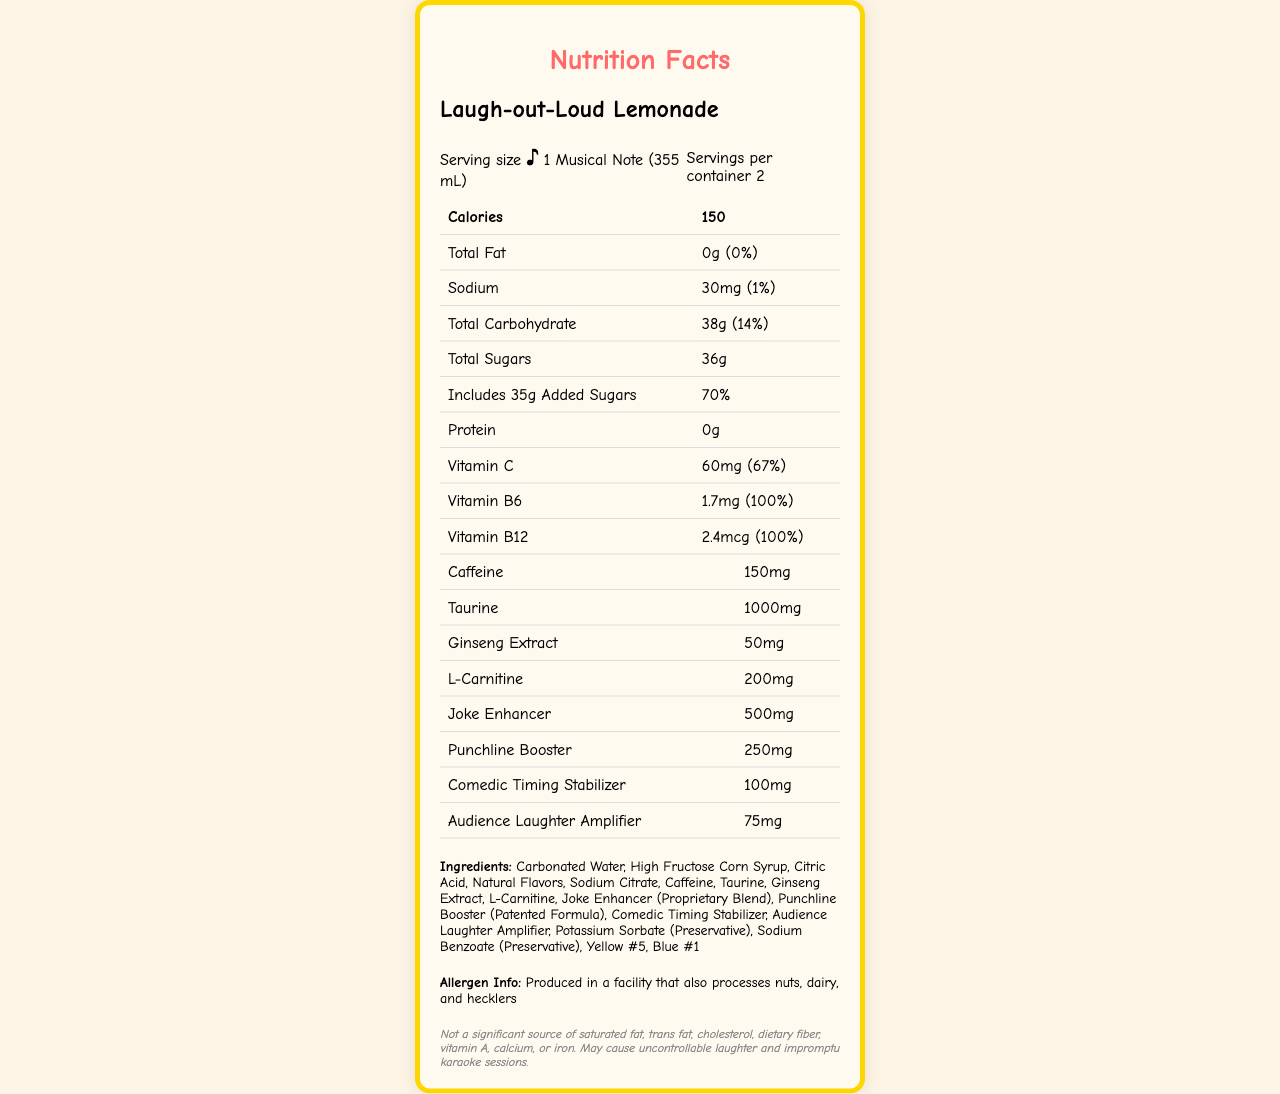what is the serving size? The serving size is stated as "1 Musical Note (355 mL)" in the serving information section at the top of the document.
Answer: 1 Musical Note (355 mL) how many calories are there per serving? The number of calories per serving is listed at the top of the nutrition information table as "Calories: 150."
Answer: 150 how much Vitamin C is in this drink? The amount of Vitamin C is given in the nutrition information table as "Vitamin C: 60mg (67%)."
Answer: 60mg (67% DV) what is the daily value percentage for added sugars? The daily value percentage for added sugars is listed as "70%" in the nutrition information table under "Includes 35g Added Sugars."
Answer: 70% list three key ingredients in the "Laugh-out-Loud Lemonade". The ingredients section lists "Carbonated Water, High Fructose Corn Syrup, Citric Acid" among other ingredients.
Answer: Carbonated Water, High Fructose Corn Syrup, Citric Acid how many servings are there per container? A. 1 B. 2 C. 3 D. 4 The servings per container are listed as "2" in the serving information section.
Answer: B which nutrient has the highest daily value percentage? i. Vitamin C ii. Vitamin B6 iii. Total Sugars iv. Sodium Vitamin B6 and Vitamin B12 both have a 100% daily value, making them the highest among listed nutrients. However, Vitamin B6 is the first listed in the nutrition information table.
Answer: ii. Vitamin B6 the drink contains artificial coloring. True or False? Yellow #5 and Blue #1 are listed in the ingredients, indicating the presence of artificial coloring.
Answer: True summarize the main idea of the document. The document outlines detailed information on the Laugh-out-Loud Lemonade energy drink, emphasizing its nutritional content, ingredients, and unique, comedy-themed additives.
Answer: The document provides detailed nutrition facts for the "Laugh-out-Loud Lemonade" energy drink, highlighting unique ingredients like "Joke Enhancer" and "Punchline Booster." It includes the serving size, calories, and various nutritional values, along with a list of ingredients, allergen information, and a humorous disclaimer. what is the amount of taurine in this energy drink? The amount of taurine is listed as "1000mg" in the table under the nutrition information.
Answer: 1000mg does the drink contain any protein? The nutrition information table lists "Protein: 0g," indicating that the drink contains no protein.
Answer: No which of the following is not listed as an ingredient in the label? A. Potassium Sorbate B. Green Tea Extract C. Yellow #5 D. Sodium Benzoate Green Tea Extract is not listed among the ingredients; the other options are.
Answer: B is this drink a significant source of dietary fiber? The disclaimer notes specifically state that the drink is not a significant source of dietary fiber.
Answer: No what specific warning is given about the effects of this drink? The disclaimer mentions this warning about the potential effects of drinking "Laugh-out-Loud Lemonade."
Answer: May cause uncontrollable laughter and impromptu karaoke sessions what is the "Joke Enhancer" amount in the drink? The nutritional table lists "Joke Enhancer: 500mg" among the unique ingredients.
Answer: 500mg what additional information does the allergen section provide? The allergen section mentions this specific detail regarding potential exposure during production.
Answer: Produced in a facility that also processes nuts, dairy, and hecklers what exact function does "Comedic Timing Stabilizer" serve according to the document? The document provides the name and amount of "Comedic Timing Stabilizer" but does not specify its exact function.
Answer: Cannot be determined 